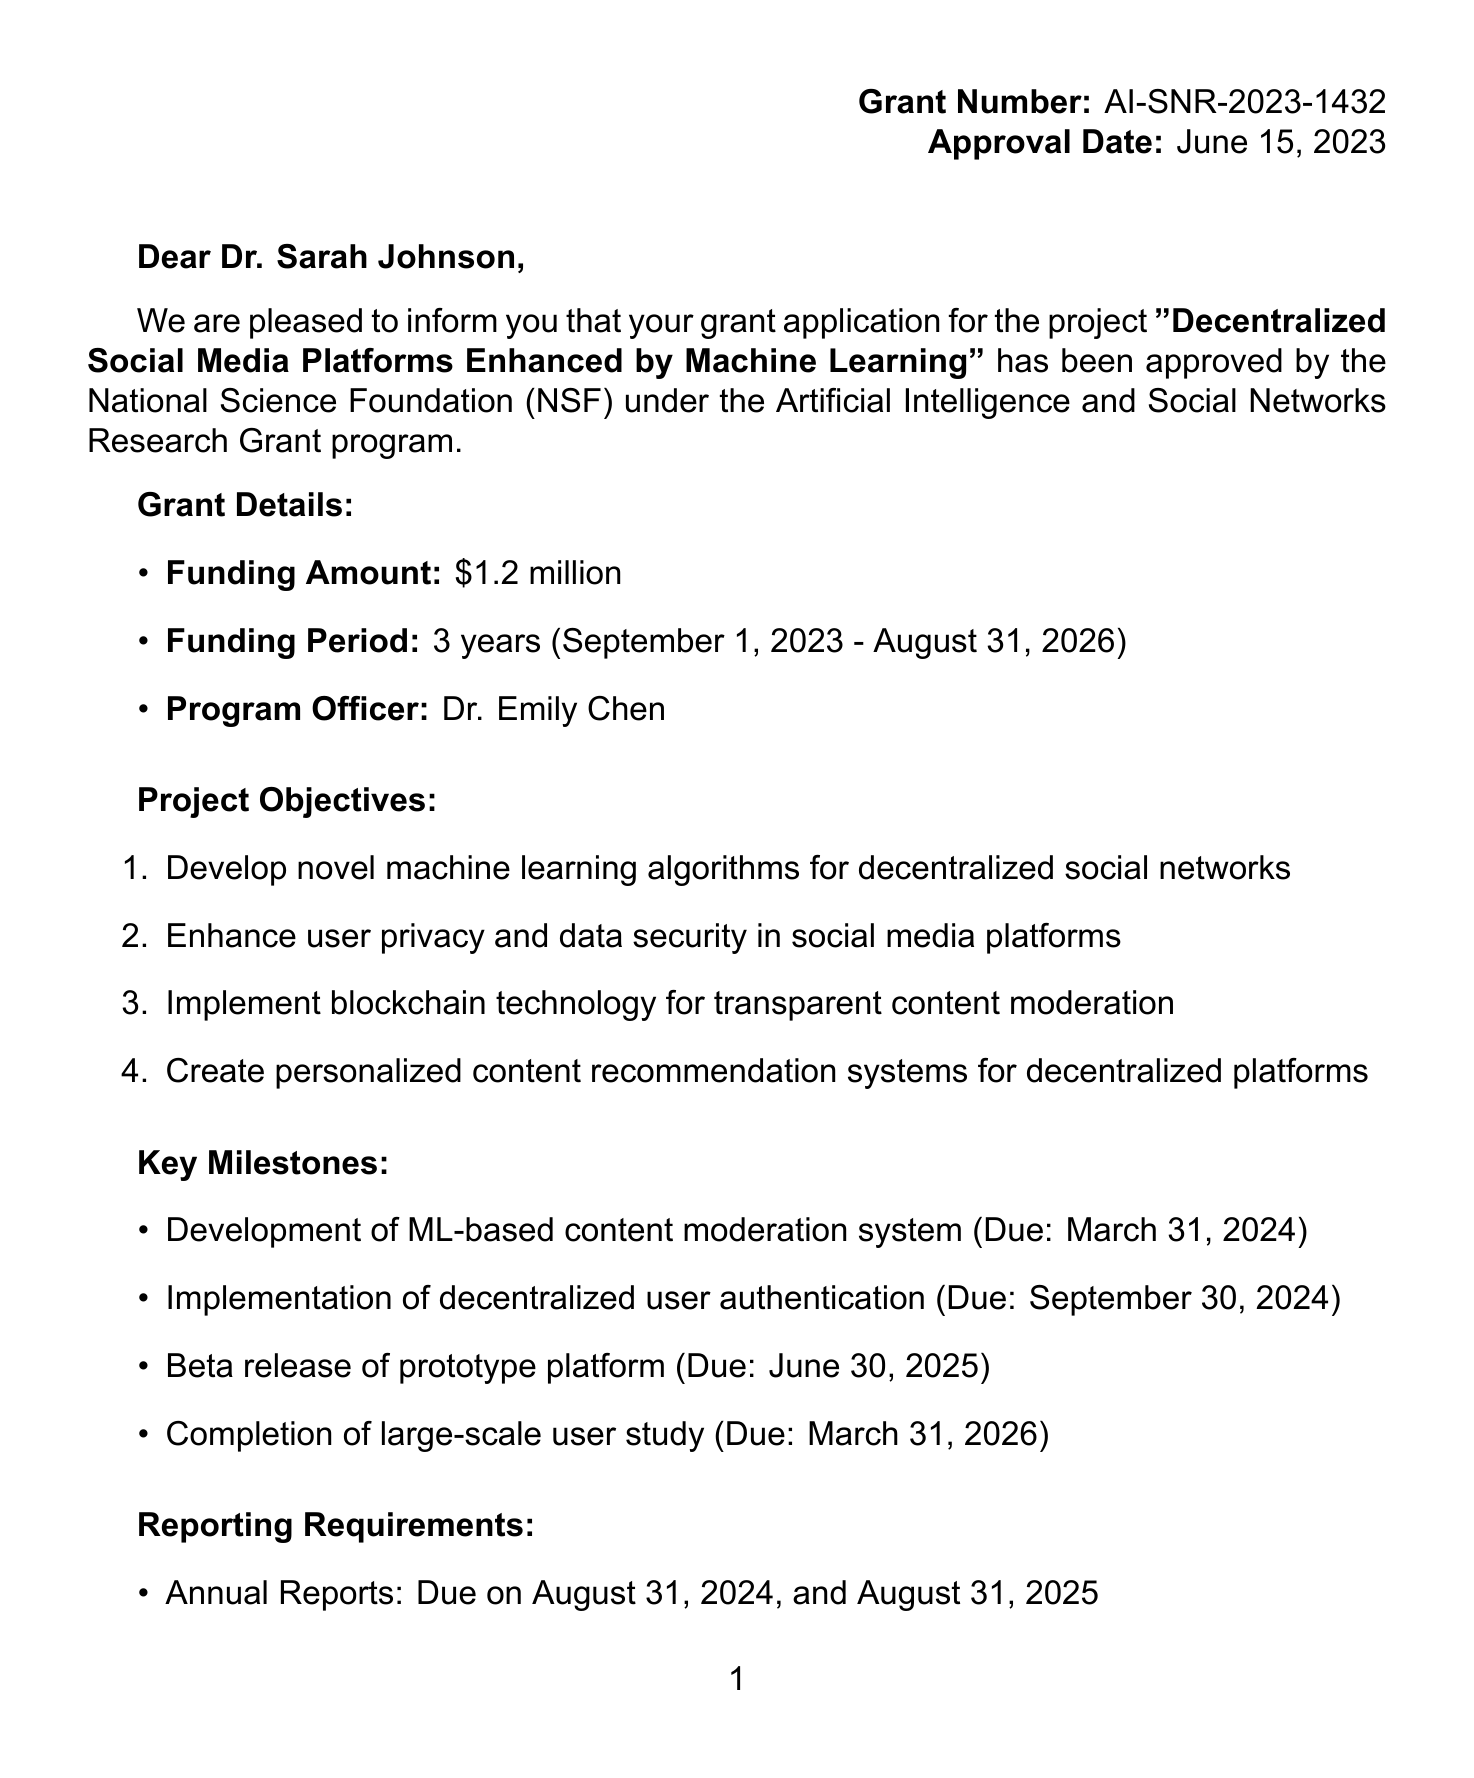What is the funding amount? The funding amount is explicitly stated in the grant details section of the document.
Answer: $1.2 million Who is the principal investigator? The principal investigator's name is mentioned in the project information section of the document.
Answer: Dr. Sarah Johnson When does the funding period start? The start date of the funding period can be found in the grant details section of the document.
Answer: September 1, 2023 What is one objective of the project? The project objectives are listed in the document, highlighting the goals of the research.
Answer: Develop novel machine learning algorithms for decentralized social networks Who is the program officer? The program officer's name is specified in the grant details section of the document.
Answer: Dr. Emily Chen What is due on November 30, 2026? The document outlines the reporting requirements along with the due dates for each report.
Answer: Final Report How many co-investigators are there? The number of co-investigators is found in the project information section which lists them.
Answer: 2 What is the name of the review panel? The name of the review panel is mentioned in the approval details section of the document.
Answer: NSF Artificial Intelligence and Network Systems Panel What is the milestone due on March 31, 2024? The key milestones are listed with their respective due dates in the document.
Answer: Development of ML-based content moderation system 